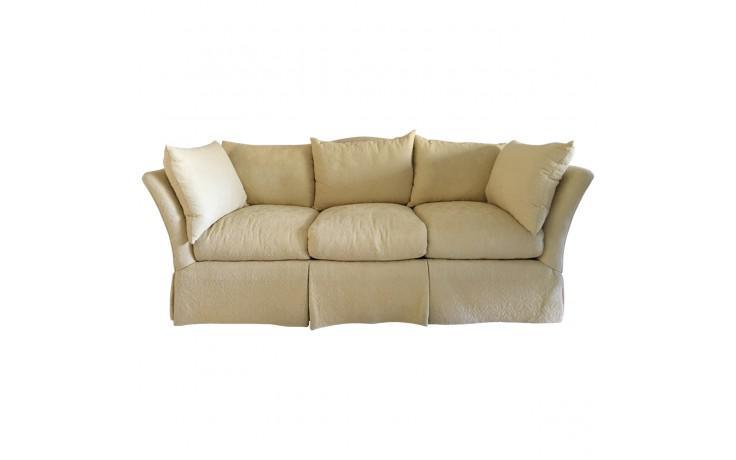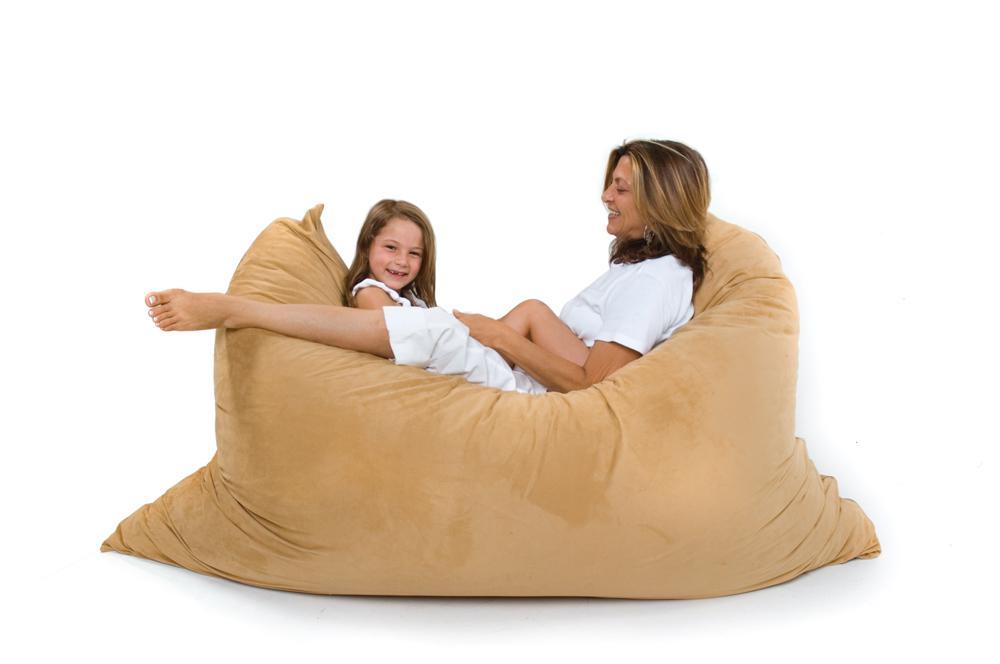The first image is the image on the left, the second image is the image on the right. For the images shown, is this caption "The lefthand image contains a vertical stack of three solid-white pillows." true? Answer yes or no. No. The first image is the image on the left, the second image is the image on the right. For the images shown, is this caption "The right image contains three pillows stacked on top of each other." true? Answer yes or no. No. 